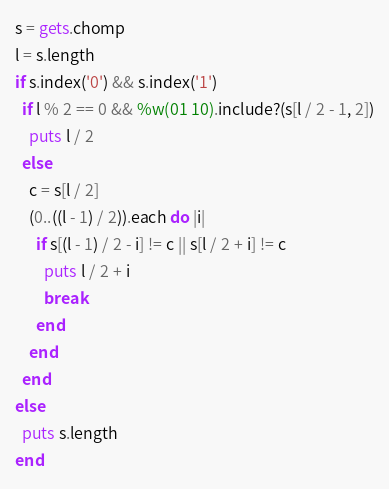Convert code to text. <code><loc_0><loc_0><loc_500><loc_500><_Ruby_>s = gets.chomp
l = s.length
if s.index('0') && s.index('1')
  if l % 2 == 0 && %w(01 10).include?(s[l / 2 - 1, 2])
    puts l / 2
  else
    c = s[l / 2]
    (0..((l - 1) / 2)).each do |i|
      if s[(l - 1) / 2 - i] != c || s[l / 2 + i] != c
        puts l / 2 + i
        break
      end
    end
  end
else
  puts s.length
end</code> 